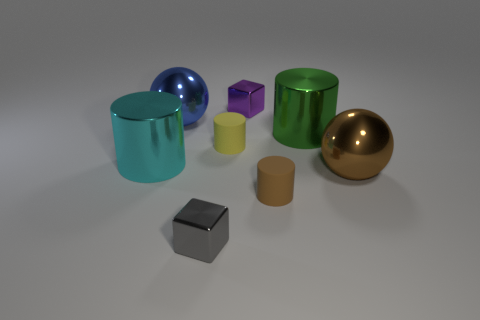What number of other objects are there of the same size as the cyan metal cylinder? 3 